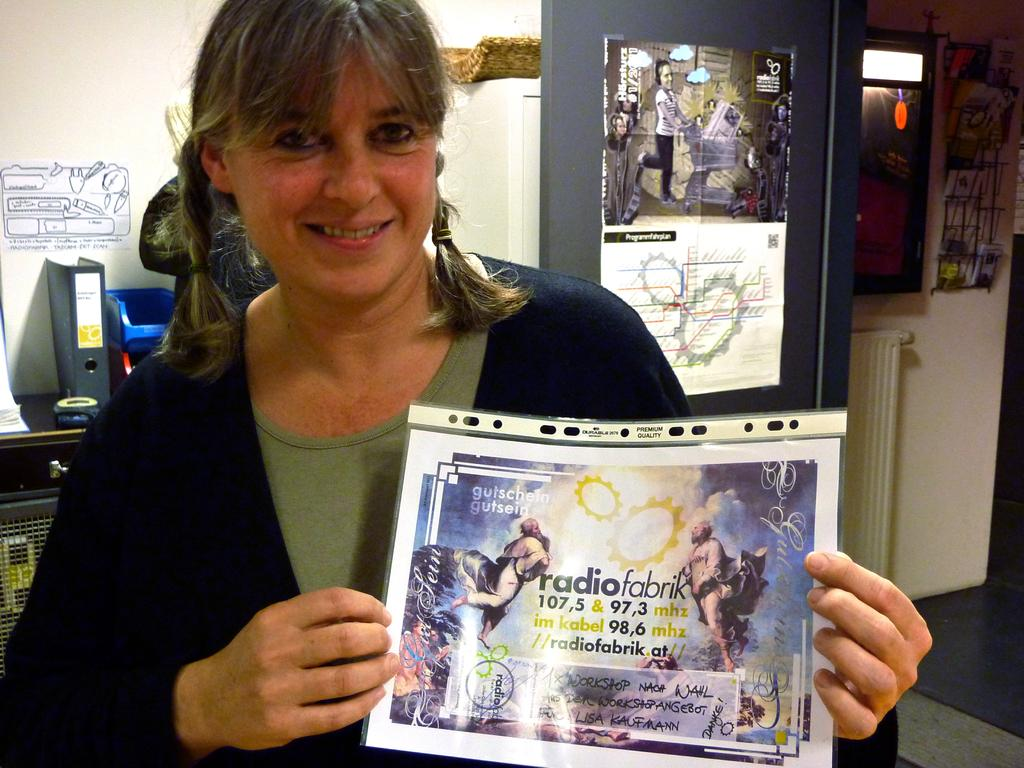<image>
Provide a brief description of the given image. A woman is holing up a flyer for a radio station called Radiofabrik 107.5 